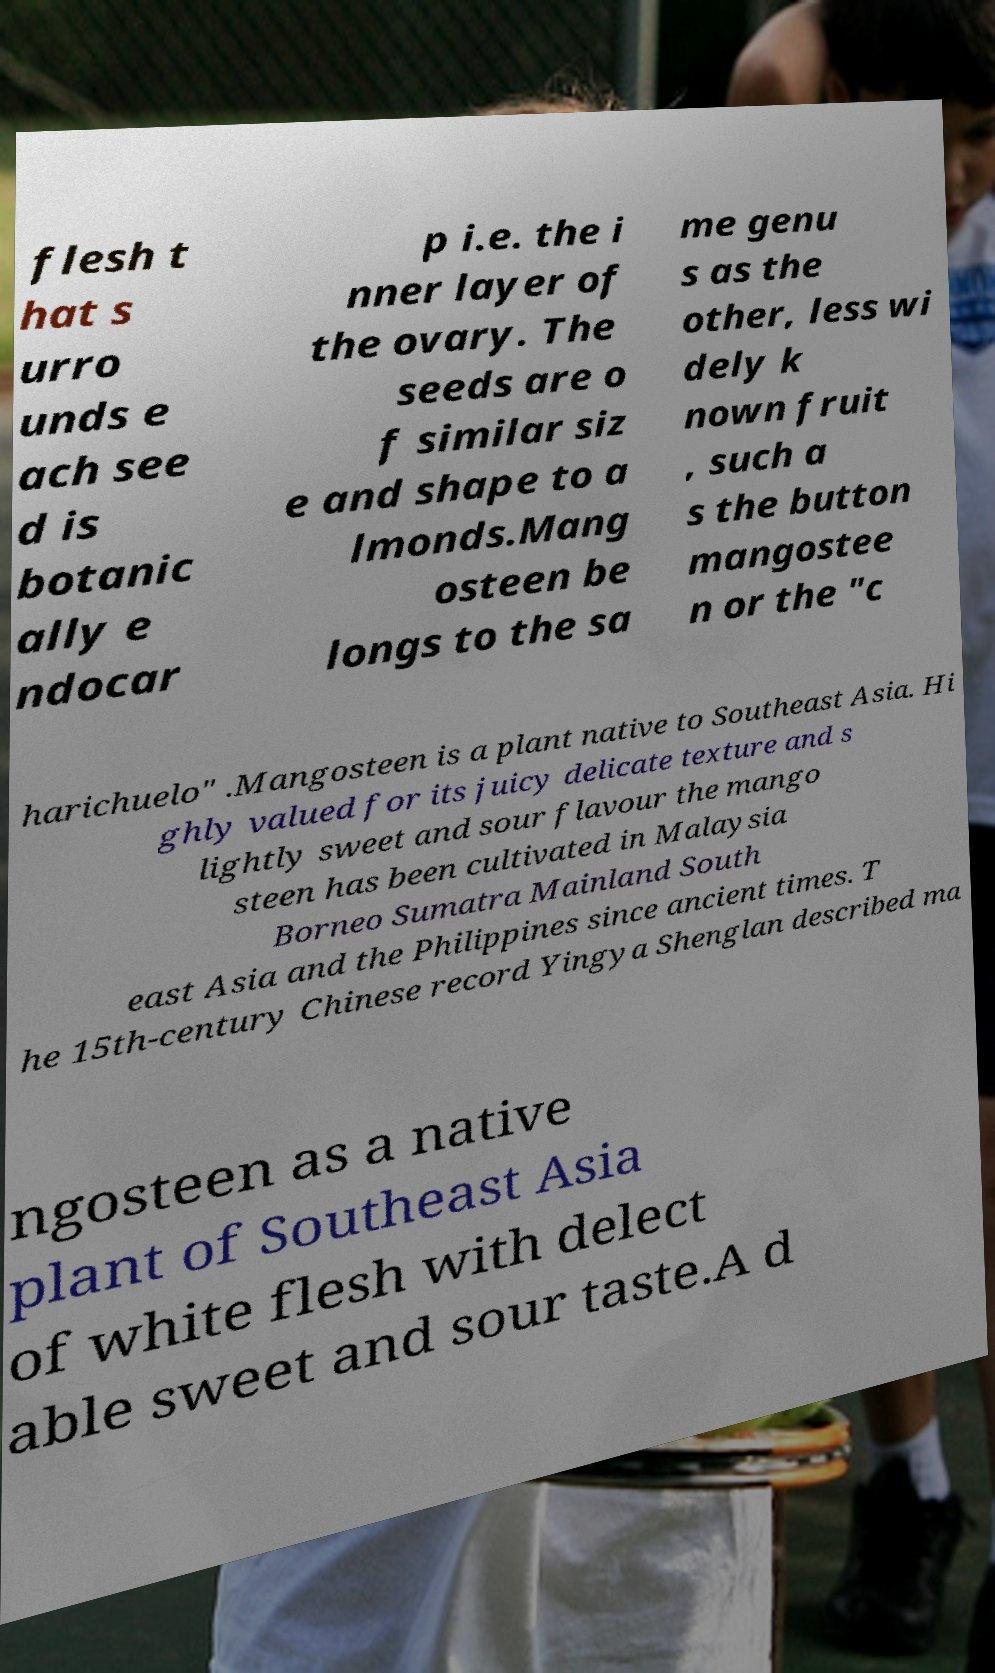Please read and relay the text visible in this image. What does it say? flesh t hat s urro unds e ach see d is botanic ally e ndocar p i.e. the i nner layer of the ovary. The seeds are o f similar siz e and shape to a lmonds.Mang osteen be longs to the sa me genu s as the other, less wi dely k nown fruit , such a s the button mangostee n or the "c harichuelo" .Mangosteen is a plant native to Southeast Asia. Hi ghly valued for its juicy delicate texture and s lightly sweet and sour flavour the mango steen has been cultivated in Malaysia Borneo Sumatra Mainland South east Asia and the Philippines since ancient times. T he 15th-century Chinese record Yingya Shenglan described ma ngosteen as a native plant of Southeast Asia of white flesh with delect able sweet and sour taste.A d 